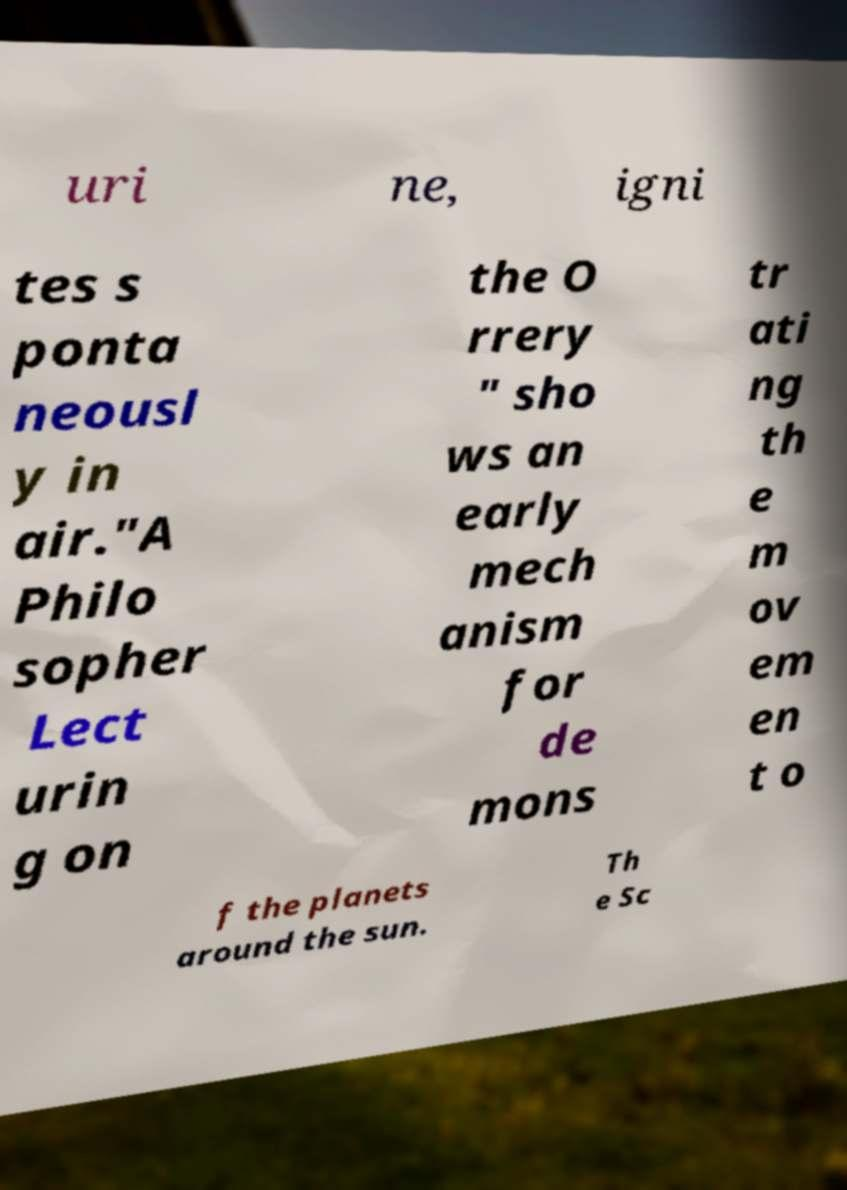Please read and relay the text visible in this image. What does it say? uri ne, igni tes s ponta neousl y in air."A Philo sopher Lect urin g on the O rrery " sho ws an early mech anism for de mons tr ati ng th e m ov em en t o f the planets around the sun. Th e Sc 